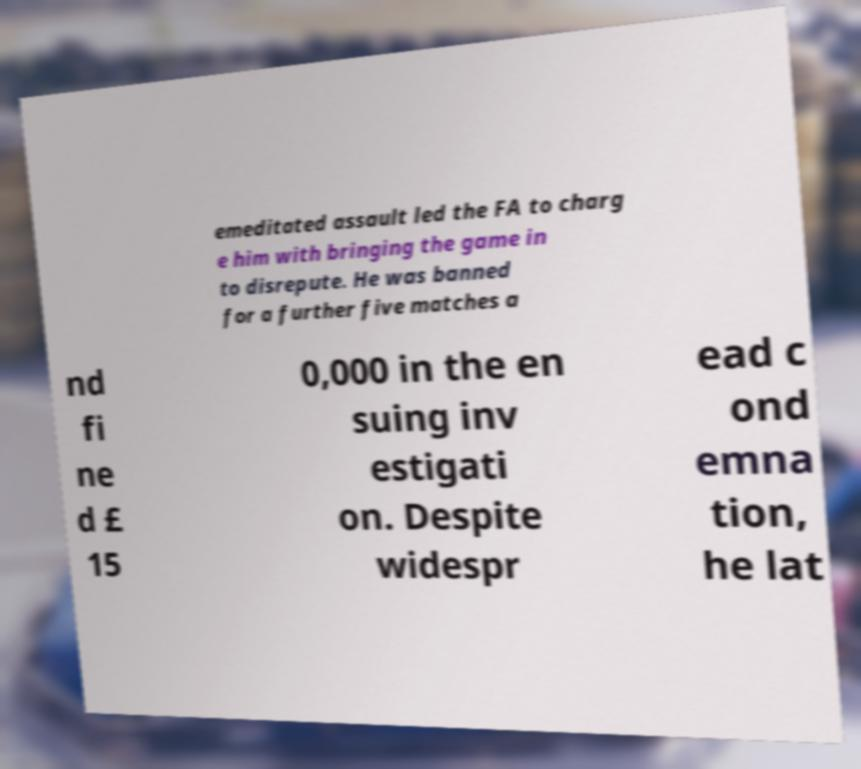What messages or text are displayed in this image? I need them in a readable, typed format. emeditated assault led the FA to charg e him with bringing the game in to disrepute. He was banned for a further five matches a nd fi ne d £ 15 0,000 in the en suing inv estigati on. Despite widespr ead c ond emna tion, he lat 